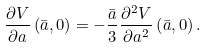Convert formula to latex. <formula><loc_0><loc_0><loc_500><loc_500>\frac { \partial V } { \partial a } \left ( \bar { a } , 0 \right ) = - \frac { \bar { a } } { 3 } \frac { \partial ^ { 2 } V } { \partial a ^ { 2 } } \left ( \bar { a } , 0 \right ) .</formula> 